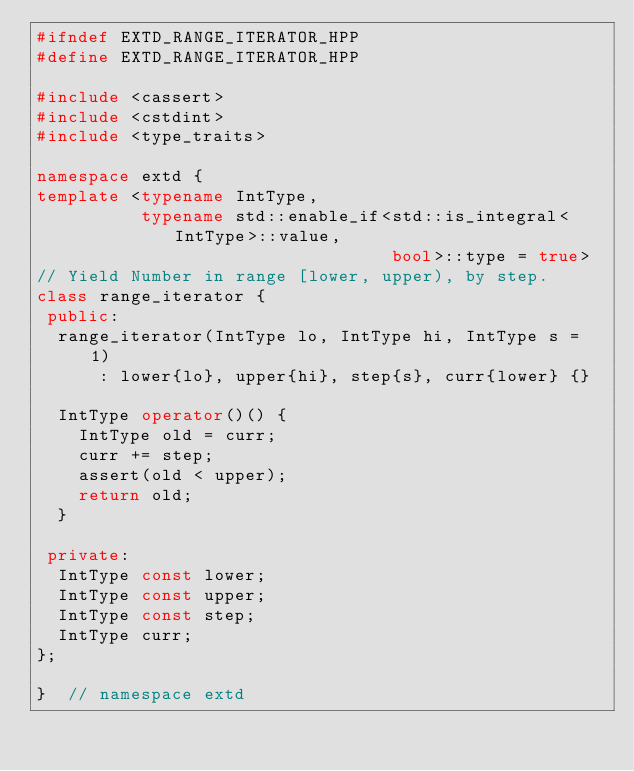<code> <loc_0><loc_0><loc_500><loc_500><_C++_>#ifndef EXTD_RANGE_ITERATOR_HPP
#define EXTD_RANGE_ITERATOR_HPP

#include <cassert>
#include <cstdint>
#include <type_traits>

namespace extd {
template <typename IntType,
          typename std::enable_if<std::is_integral<IntType>::value,
                                  bool>::type = true>
// Yield Number in range [lower, upper), by step.
class range_iterator {
 public:
  range_iterator(IntType lo, IntType hi, IntType s = 1)
      : lower{lo}, upper{hi}, step{s}, curr{lower} {}

  IntType operator()() {
    IntType old = curr;
    curr += step;
    assert(old < upper);
    return old;
  }

 private:
  IntType const lower;
  IntType const upper;
  IntType const step;
  IntType curr;
};

}  // namespace extd
</code> 